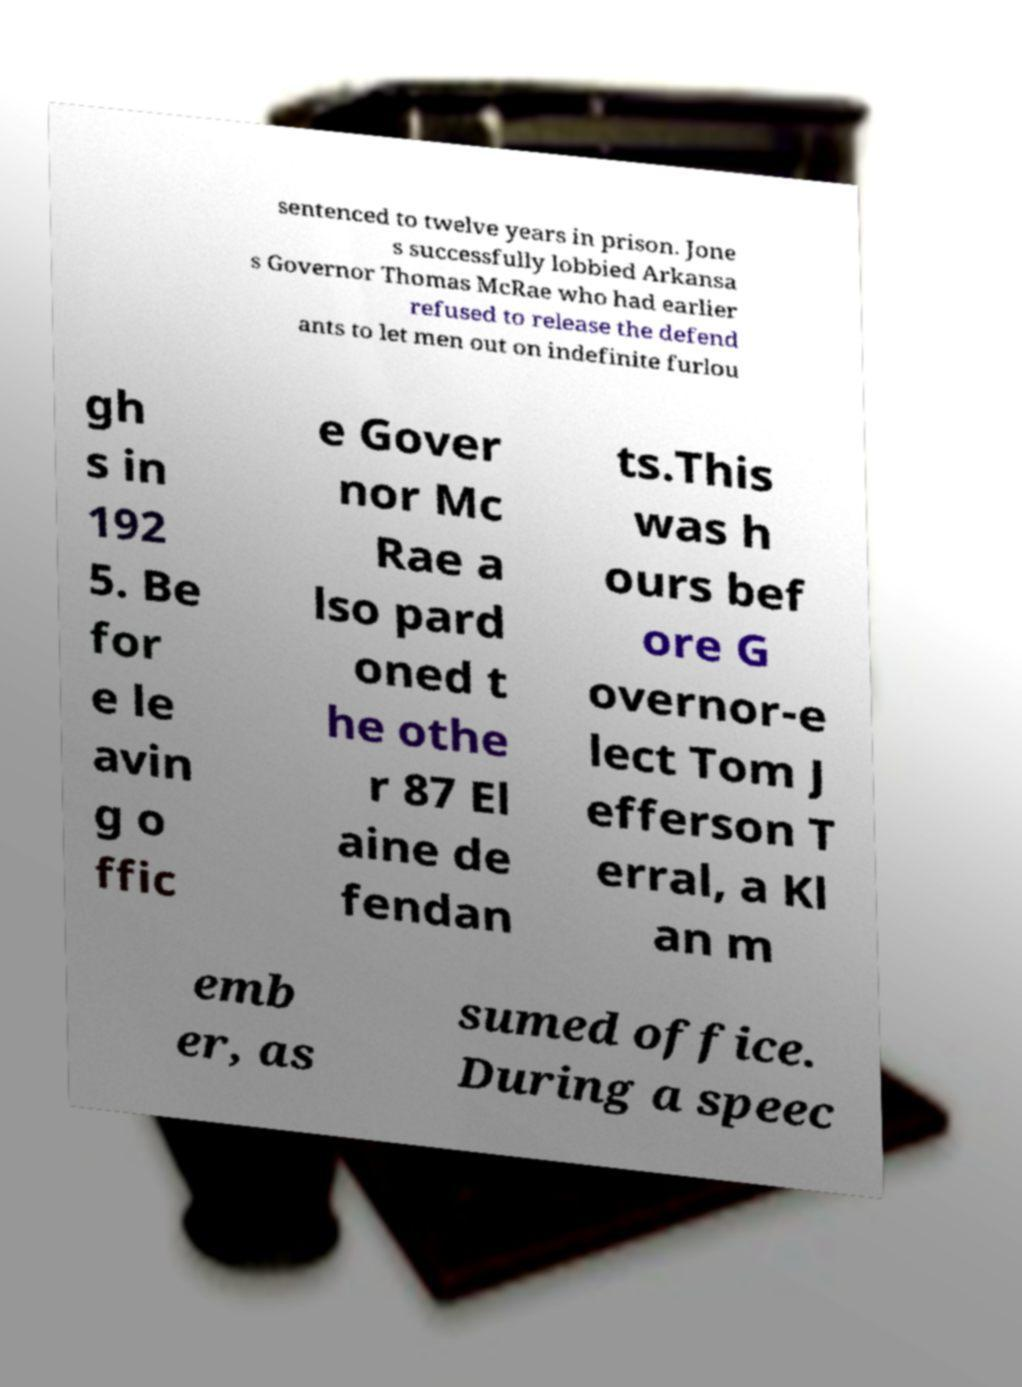Can you read and provide the text displayed in the image?This photo seems to have some interesting text. Can you extract and type it out for me? sentenced to twelve years in prison. Jone s successfully lobbied Arkansa s Governor Thomas McRae who had earlier refused to release the defend ants to let men out on indefinite furlou gh s in 192 5. Be for e le avin g o ffic e Gover nor Mc Rae a lso pard oned t he othe r 87 El aine de fendan ts.This was h ours bef ore G overnor-e lect Tom J efferson T erral, a Kl an m emb er, as sumed office. During a speec 